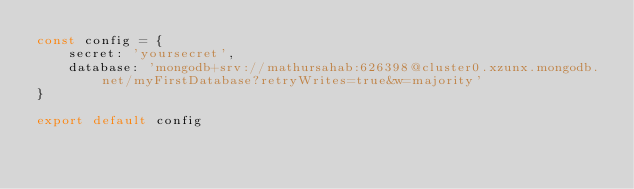<code> <loc_0><loc_0><loc_500><loc_500><_JavaScript_>const config = {
    secret: 'yoursecret',
    database: 'mongodb+srv://mathursahab:626398@cluster0.xzunx.mongodb.net/myFirstDatabase?retryWrites=true&w=majority'
}

export default config</code> 